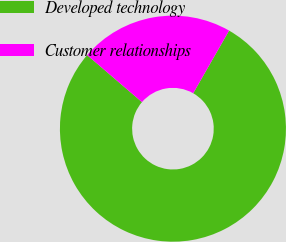Convert chart. <chart><loc_0><loc_0><loc_500><loc_500><pie_chart><fcel>Developed technology<fcel>Customer relationships<nl><fcel>78.01%<fcel>21.99%<nl></chart> 